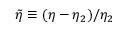Convert formula to latex. <formula><loc_0><loc_0><loc_500><loc_500>\tilde { \eta } \equiv ( \eta - \eta _ { 2 } ) / \eta _ { 2 }</formula> 